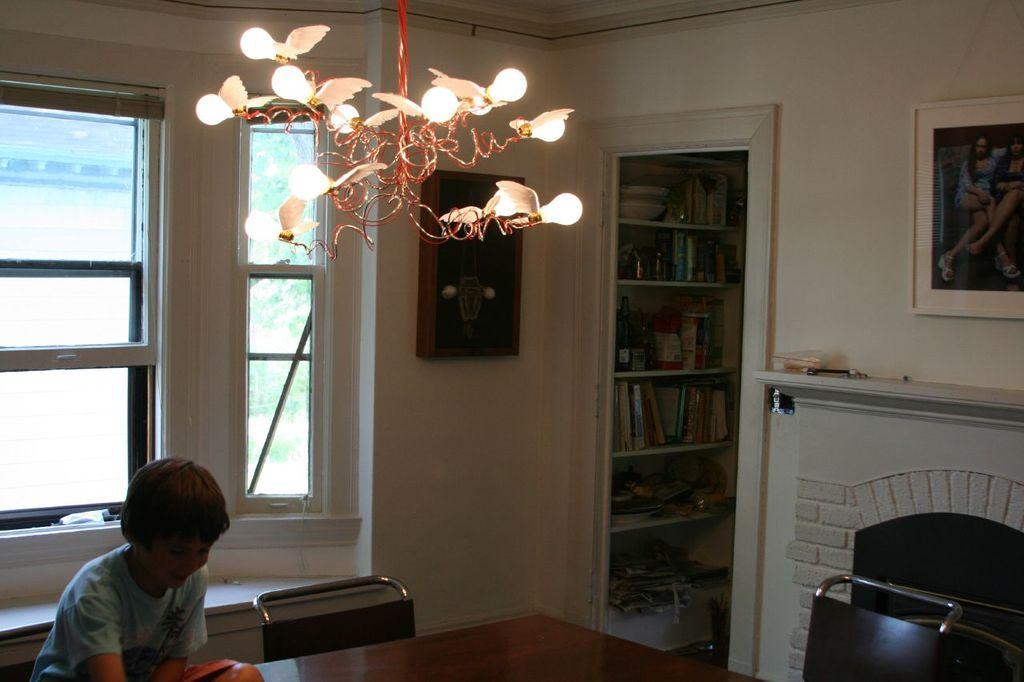What is the child doing in the image? The child is sitting on the table. What can be seen in the image that provides illumination? There are lights visible in the image. What is hanging on the wall in the image? There is a photo frame on the wall. What can be seen in the background of the image? There is a fireplace, books, a cupboard, and a window glass in the background. What type of vacation is the child planning based on the image? There is no indication in the image that the child is planning a vacation or has any connection to an airport or bath. 